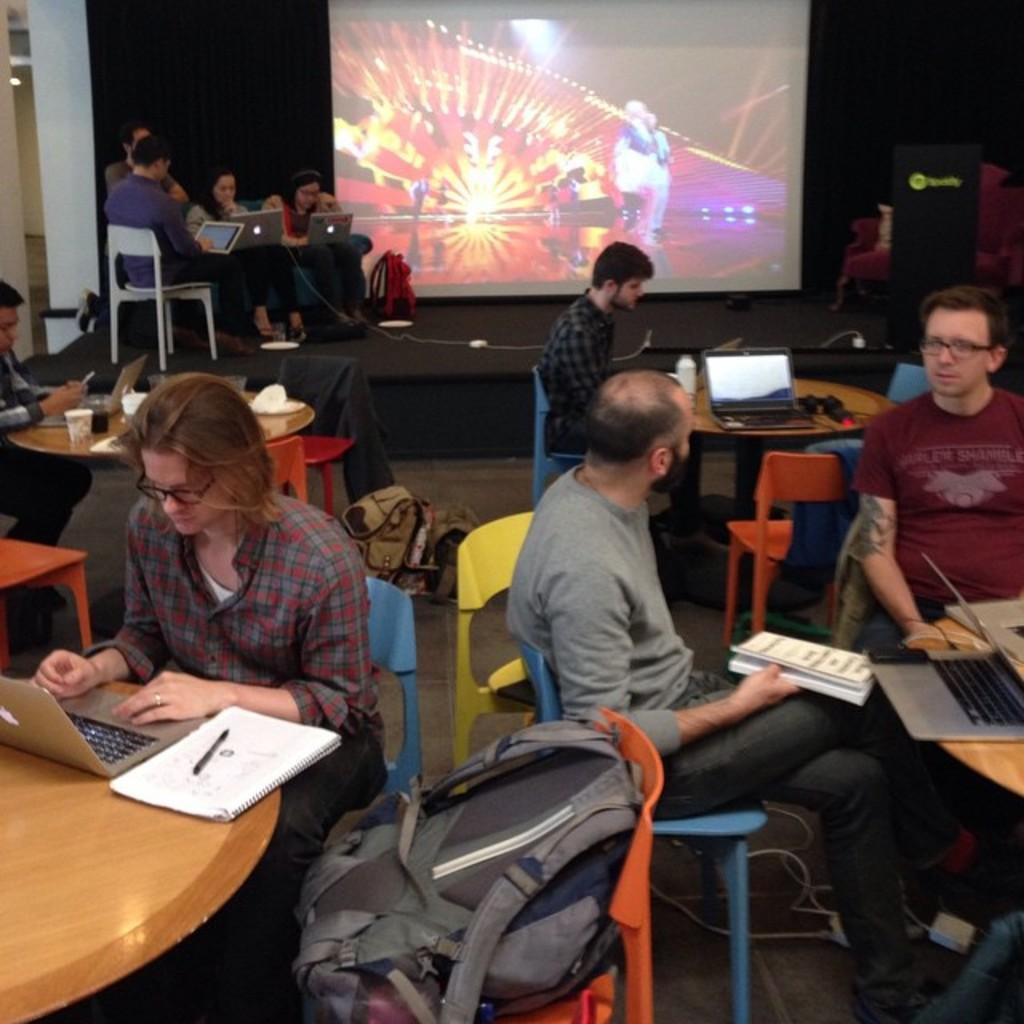How many people are in the image? There are several people in the image. What are the people doing in the image? The people are sitting at a table. What tools are the people using in the image? The people have laptops and notebooks. What can be seen in the background of the image? There is a projector screen in the background. Are the people sleeping in the image? No, the people are not sleeping in the image; they are sitting at a table with laptops and notebooks. Can you see a tub in the image? No, there is no tub present in the image. 